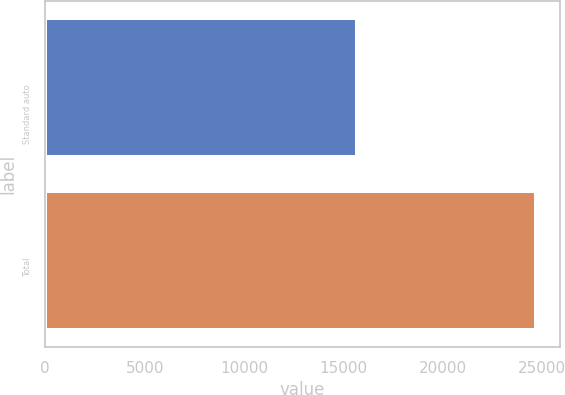Convert chart to OTSL. <chart><loc_0><loc_0><loc_500><loc_500><bar_chart><fcel>Standard auto<fcel>Total<nl><fcel>15679<fcel>24663<nl></chart> 